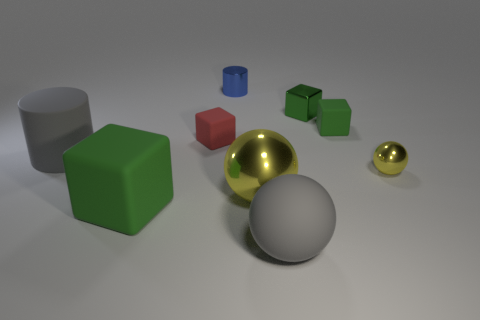Subtract all purple spheres. How many green blocks are left? 3 Add 1 small purple rubber things. How many objects exist? 10 Subtract all purple cubes. Subtract all gray spheres. How many cubes are left? 4 Subtract all spheres. How many objects are left? 6 Subtract 0 yellow cylinders. How many objects are left? 9 Subtract all big yellow rubber cylinders. Subtract all small red blocks. How many objects are left? 8 Add 1 metal cylinders. How many metal cylinders are left? 2 Add 3 large gray matte balls. How many large gray matte balls exist? 4 